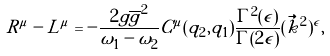Convert formula to latex. <formula><loc_0><loc_0><loc_500><loc_500>R ^ { \mu } - L ^ { \mu } = - \frac { 2 g \overline { g } ^ { 2 } } { \omega _ { 1 } - \omega _ { 2 } } C ^ { \mu } ( q _ { 2 } , q _ { 1 } ) \frac { \Gamma ^ { 2 } ( \epsilon ) } { \Gamma ( 2 \epsilon ) } ( \vec { k } ^ { 2 } ) ^ { \epsilon } ,</formula> 